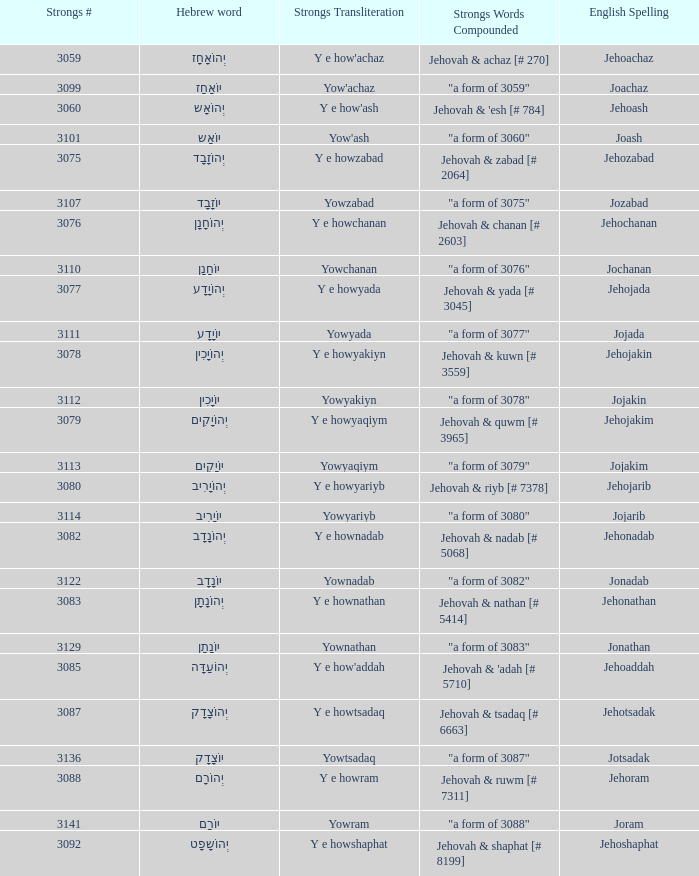What is the strongs # associated with the english representation of jehojakin? 3078.0. 